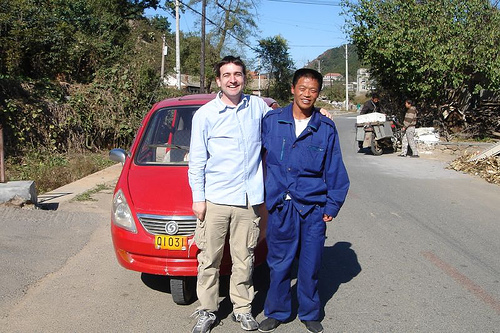<image>
Is there a red car in front of the man? No. The red car is not in front of the man. The spatial positioning shows a different relationship between these objects. Is there a road in front of the man? No. The road is not in front of the man. The spatial positioning shows a different relationship between these objects. 